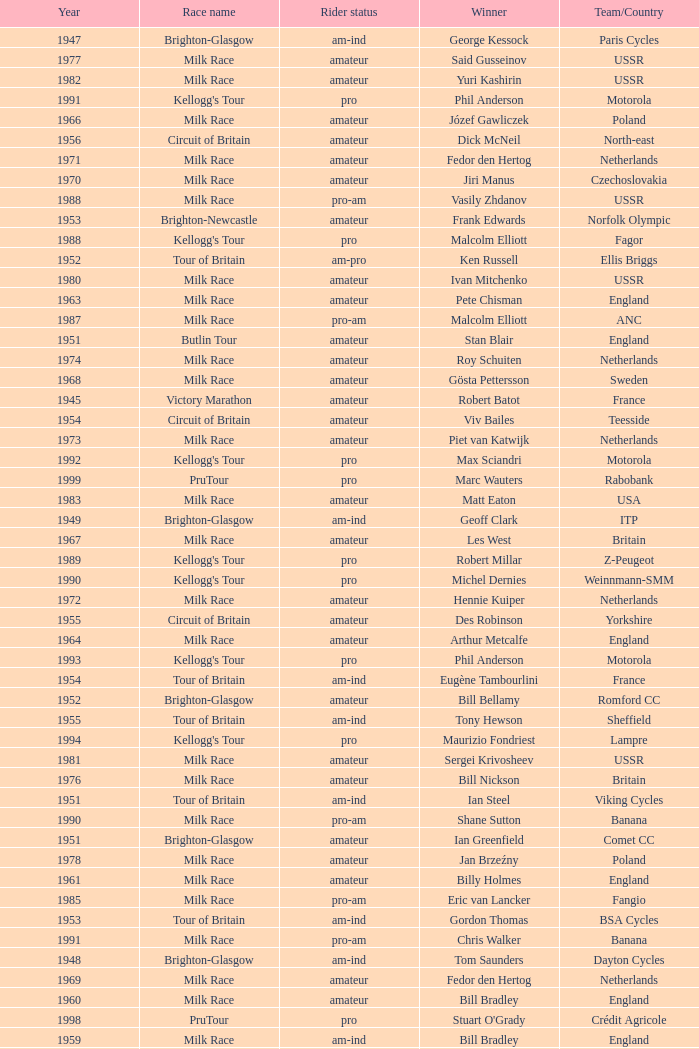What is the rider status for the 1971 netherlands team? Amateur. 